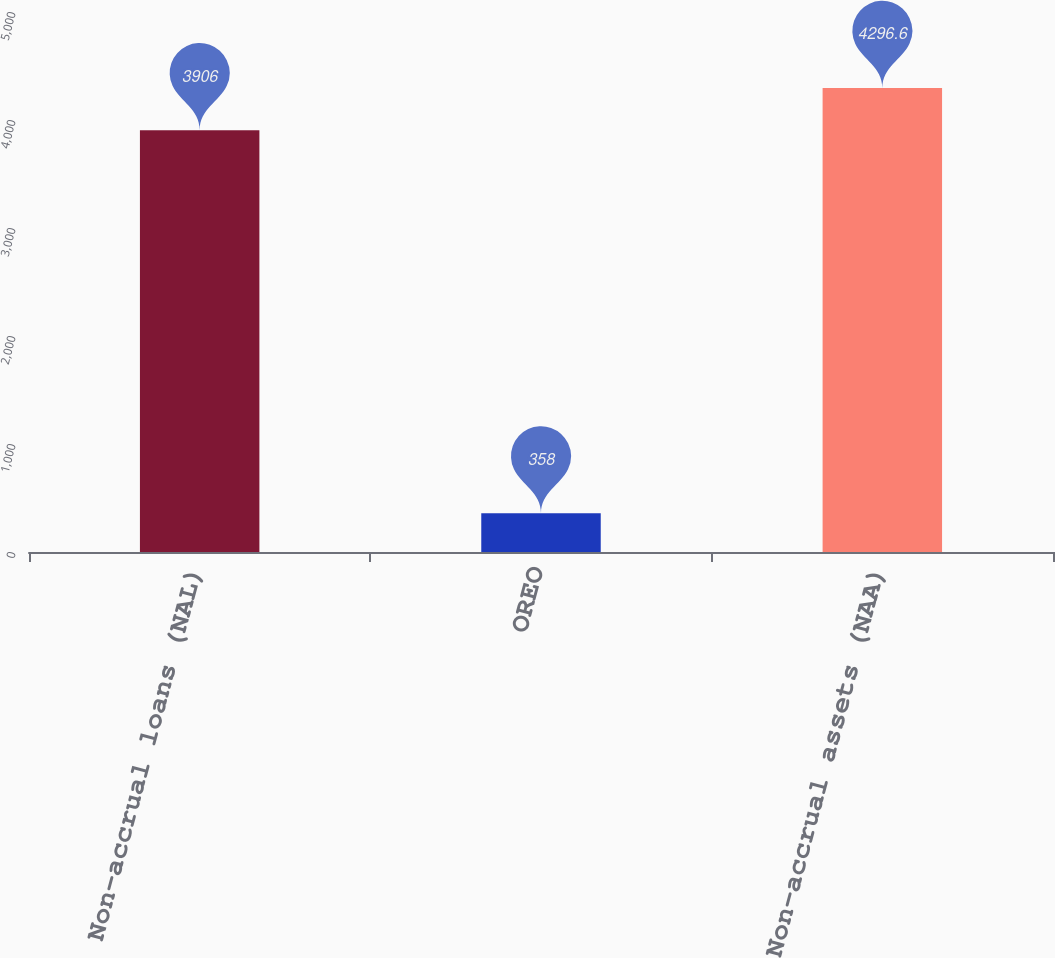Convert chart to OTSL. <chart><loc_0><loc_0><loc_500><loc_500><bar_chart><fcel>Non-accrual loans (NAL)<fcel>OREO<fcel>Non-accrual assets (NAA)<nl><fcel>3906<fcel>358<fcel>4296.6<nl></chart> 